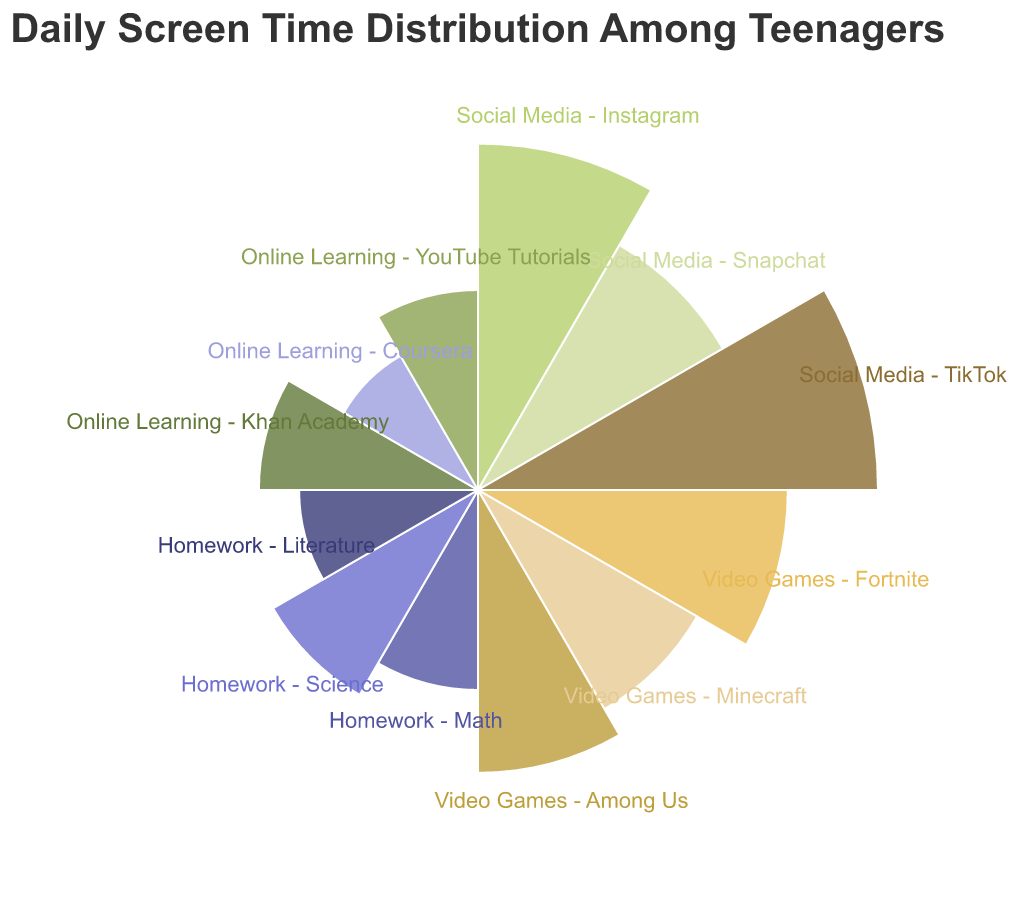What is the category with the highest daily screen time? By visually inspecting the lengths of the bars or segments in the Polar Chart, we can see which category has the longest radius or arc, indicating the highest daily screen time.
Answer: Social Media - TikTok What is the total daily screen time spent on Social Media? By adding up the screen time for Instagram, Snapchat, and TikTok from the data: 1.5 + 1.0 + 2.0 hours.
Answer: 4.5 hours How does the screen time for Video Games compare to Online Learning? Summing up the screen time for all categories in Video Games and Online Learning, we get: Fortnite (1.2) + Minecraft (0.8) + Among Us (1.0) = 3 hours for Video Games and Khan Academy (0.6) + Coursera (0.3) + YouTube Tutorials (0.5) = 1.4 hours for Online Learning. Comparing them shows that Video Games have a greater screen time than Online Learning.
Answer: Video Games have more screen time Which category within Homework has the least screen time? From the polar chart, we find the shortest bar or arc within the Homework category. The times are: Math (0.5), Science (0.7), and Literature (0.4). Literature has the least screen time.
Answer: Homework - Literature What is the average daily screen time for Homework activities? Calculate the average by summing up the screen times for Math, Science, and Literature, then dividing by the number of Homework activities: (0.5 + 0.7 + 0.4) / 3.
Answer: 0.53 hours If you could reduce Social Media time by one hour daily, what would be the new total time for Social Media? Subtracting 1 hour from the total daily screen time for Social Media: 4.5 hours - 1 hour.
Answer: 3.5 hours What is the difference in daily screen time between the most and least used Social Media platforms? The most used is TikTok (2.0 hours) and the least used is Snapchat (1.0 hour). The difference is 2.0 - 1.0 hours.
Answer: 1.0 hour How many categories of daily activities are represented in the Polar Chart? Count the number of distinct categories (Social Media, Video Games, Homework, Online Learning) shown in the chart.
Answer: 4 categories Which has more screen time: Fortnite or Online Learning combined? Compare the time for Fortnite (1.2 hours) with the combined Online Learning time (1.4 hours).
Answer: Online Learning What is the combined screen time for coursera and youtube tutorials? Summing up the hours for Coursera and YouTube Tutorials: 0.3 + 0.5
Answer: 0.8 hours 